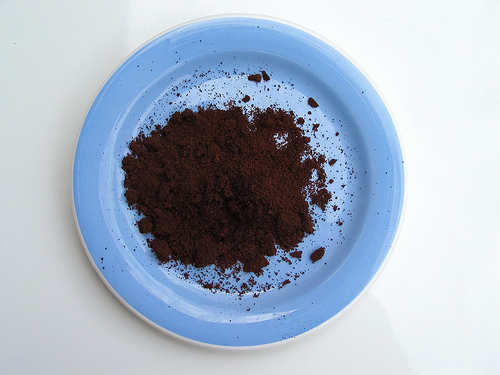<image>
Can you confirm if the coffee powder is on the table? Yes. Looking at the image, I can see the coffee powder is positioned on top of the table, with the table providing support. 